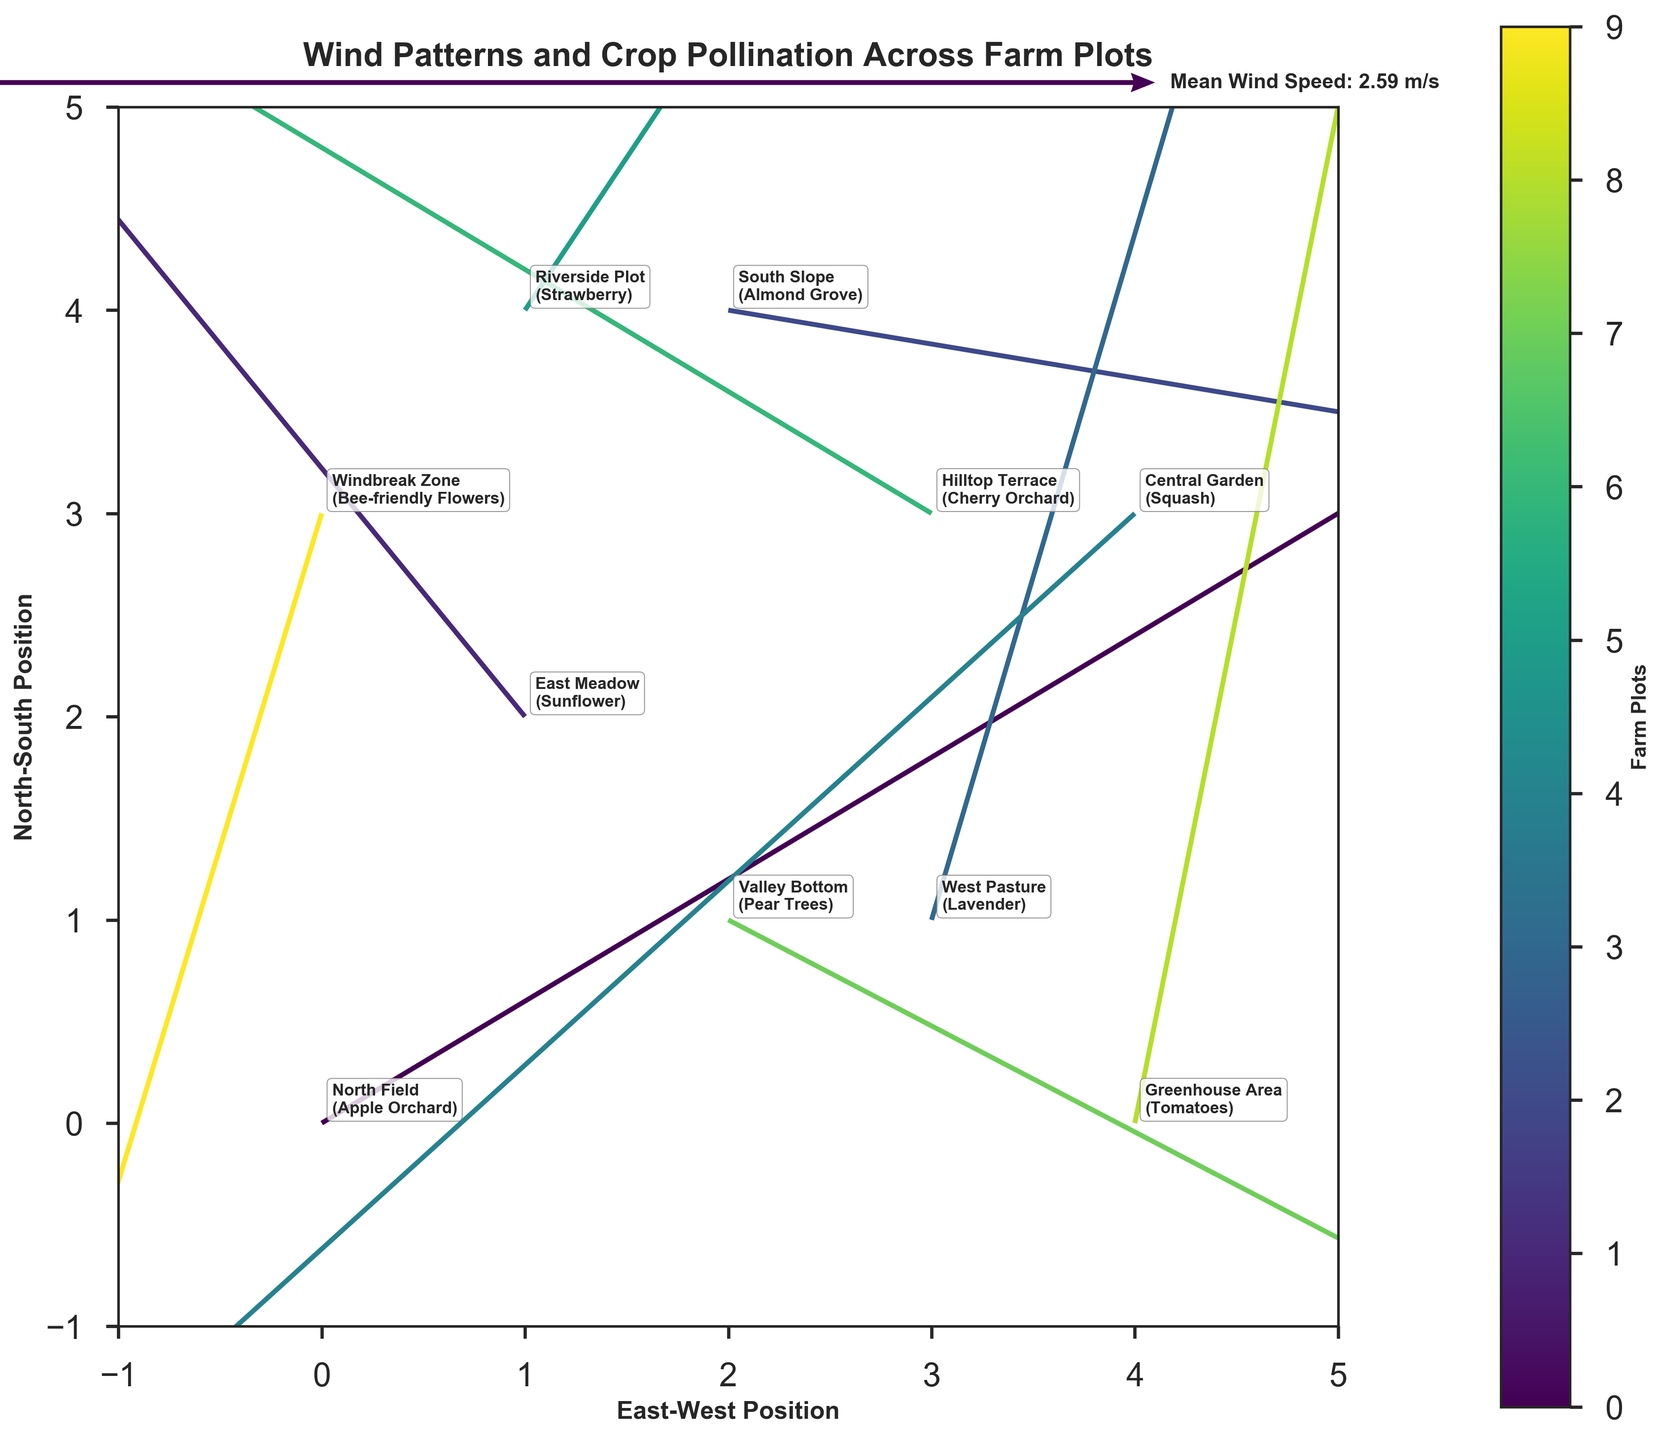What is the title of the figure? The title is usually positioned at the top center of the plot, making it easy to identify.
Answer: Wind Patterns and Crop Pollination Across Farm Plots Which farm plot experiences the strongest eastward wind? To determine the strongest eastward wind, look at the 'u' component of the vectors (east-west direction) and find the highest positive value. The 'u' component value for the highest positive is 3.0 at South Slope.
Answer: South Slope Compare the wind direction in the North Field and Central Garden. Which one has a more southerly wind? To compare the southerly direction, look at the 'v' component of the vectors (north-south direction). A more negative 'v' value indicates a stronger southerly wind. North Field has a 'v' of 1.5, while Central Garden has a 'v' of -1.9, meaning Central Garden has a more southerly wind.
Answer: Central Garden What is the mean wind speed depicted in the figure? The mean wind speed is provided in the figure legend as "Mean Wind Speed: X.XX m/s". This summarization is a built-in feature of the figure.
Answer: Mean Wind Speed: (depends on the specific computation in the figure's legend, e.g., 2.23 m/s) How does the wind pattern differ between the East Meadow and the West Pasture? From the arrows, the East Meadow shows a wind vector with components (-1.8, 2.2) indicating a northeast direction, while the West Pasture shows (0.8, 2.7), indicating a north-northeast direction. This means the East Meadow experiences a more easterly wind than the West Pasture.
Answer: East Meadow is more easterly than West Pasture Which crop type in the figure has the smallest vector magnitude, and what is it? To find the smallest magnitude, calculate the vectors' magnitudes (sqrt(u^2 + v^2)) for all crop types and identify the smallest value. The smallest value is determined by calculation, which, in this case, is for the Windbreak Zone: sqrt((-0.7)^2 + (-2.3)^2) ≈ 2.41 m/s.
Answer: Windbreak Zone, 2.41 m/s Are there any farm plots where the wind is purely vertical (either north or south)? A vector is purely vertical if the 'u' component (east-west) is zero. Looking at the data, none of the entries have 'u' = 0.0, indicating no purely vertical wind.
Answer: No Which crop type at Riverside Plot are impacted by wind? Riverside Plot is annotated on the left side of the graph, adjacent to the arrows representing it. The crop type listed for this plot is Strawberry.
Answer: Strawberry What is the general wind direction for the Greenhouse Area? The vector for the Greenhouse Area is (0.5, 2.5), indicating a northeast wind direction. The arrow will show primarily northward with a slight eastward incline.
Answer: Northeast Describe the wind condition for crop pollination at Hilltop Terrace. The vector for the Hilltop Terrace is (-1.5, 0.9), indicating northwest wind direction. This means wind here is predominantly westerly with a moderate northern component.
Answer: Northwest 